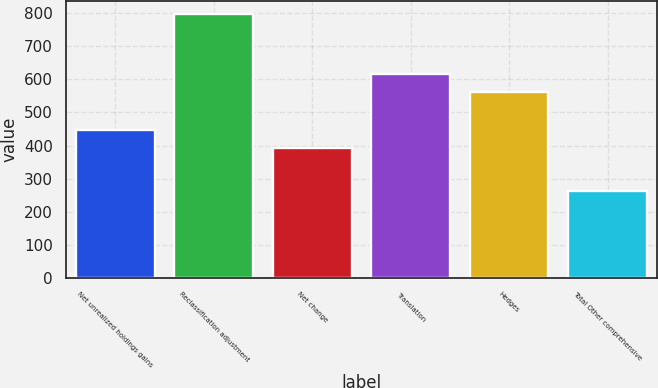Convert chart. <chart><loc_0><loc_0><loc_500><loc_500><bar_chart><fcel>Net unrealized holdings gains<fcel>Reclassification adjustment<fcel>Net change<fcel>Translation<fcel>Hedges<fcel>Total Other comprehensive<nl><fcel>447.3<fcel>797<fcel>394<fcel>616.3<fcel>563<fcel>264<nl></chart> 